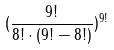<formula> <loc_0><loc_0><loc_500><loc_500>( \frac { 9 ! } { 8 ! \cdot ( 9 ! - 8 ! ) } ) ^ { 9 ! }</formula> 